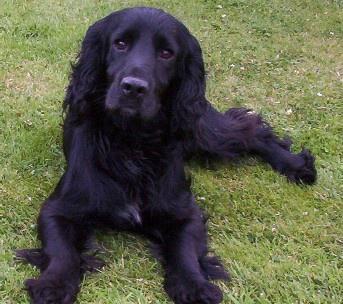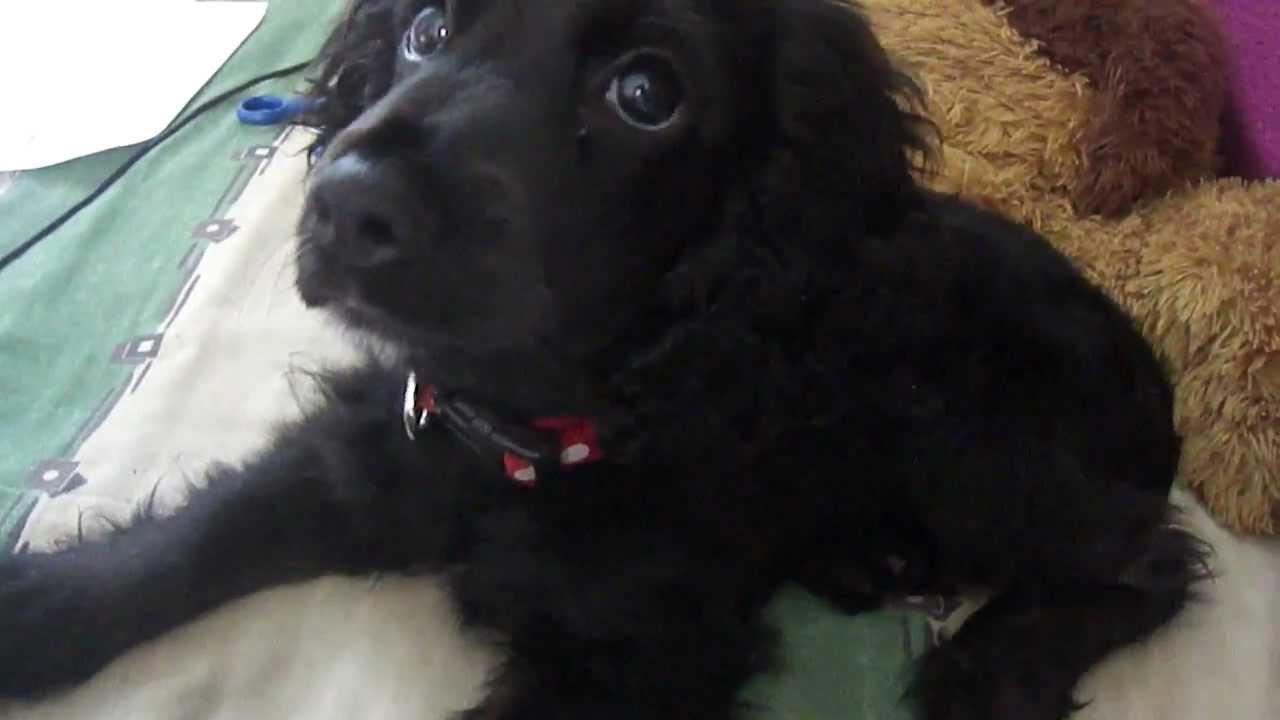The first image is the image on the left, the second image is the image on the right. Analyze the images presented: Is the assertion "The left image contains two dark dogs." valid? Answer yes or no. No. The first image is the image on the left, the second image is the image on the right. For the images displayed, is the sentence "Two puppies sit together in the image on the left." factually correct? Answer yes or no. No. 